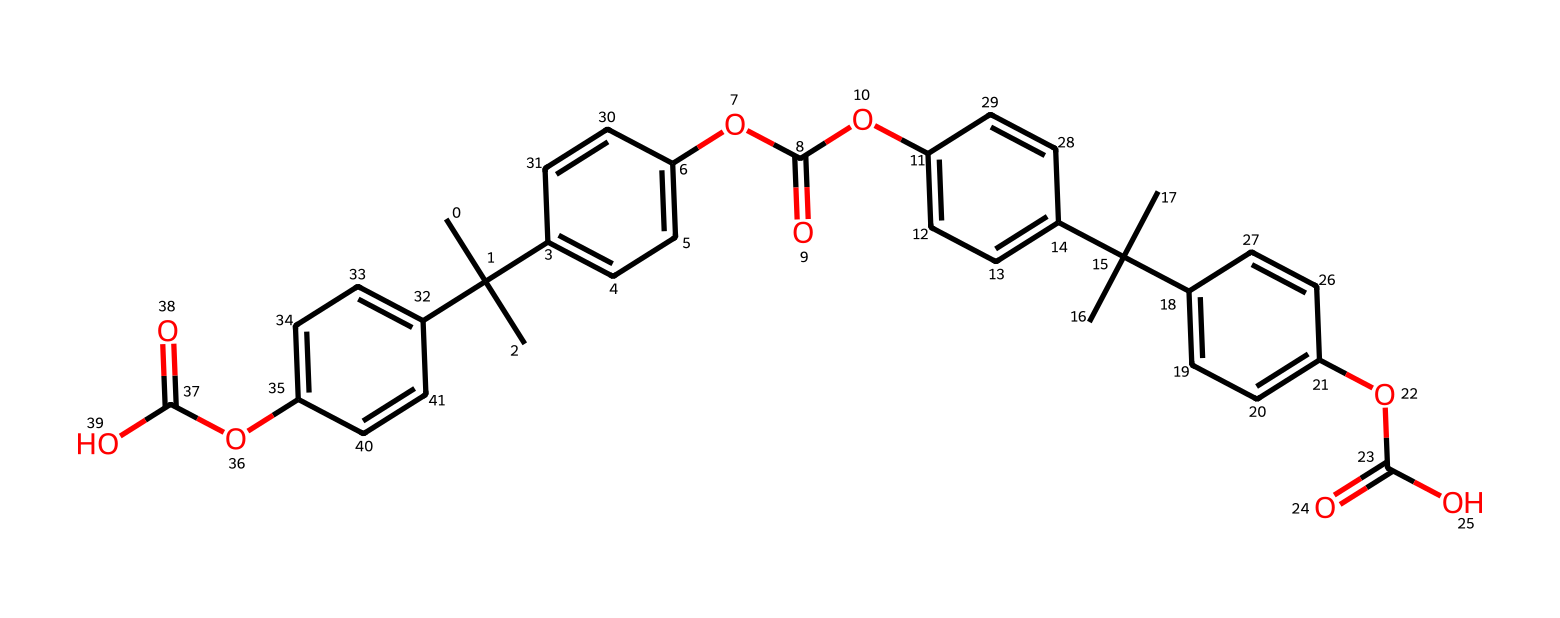How many carbon atoms are in this polymer? By examining the SMILES representation, we can count the 'C' characters that represent carbon atoms. The structure reveals that there are 27 carbon atoms in total.
Answer: 27 What functional groups are present in this chemical? The chemical contains ester groups, indicated by the notation 'OC(=O)', which appear multiple times in the SMILES string. This signifies the presence of -COO- functional groups typical for polycarbonate.
Answer: ester How many aromatic rings are there in this polymer? The presence of ‘c’ in the SMILES indicates aromatic carbon atoms. By counting the occurrences of distinct aromatic systems in the structure, we find there are 4 aromatic rings present.
Answer: 4 What is the degree of branching in the carbon chain? The presence of branching is identified by the notation ‘C(C)(C)’, indicating tertiary carbon atoms that connect to three other carbon atoms. This implies significant branching in the structure.
Answer: high What type of polymerization process is likely involved in forming this polycarbonate? Polycarbonate is typically formed through step-growth polymerization involving diols and diacids, which can be deduced from the repeating ester linkages in the chemical structure.
Answer: step-growth What property of polycarbonate makes it suitable for protective screens? The structural integrity of polycarbonate is enhanced by its high impact resistance due to the presence of strong molecular bonds within the polymer backbone, making it ideal for protective applications.
Answer: impact resistance 